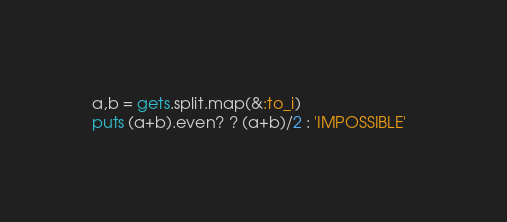<code> <loc_0><loc_0><loc_500><loc_500><_Ruby_>a,b = gets.split.map(&:to_i)
puts (a+b).even? ? (a+b)/2 : 'IMPOSSIBLE'  </code> 